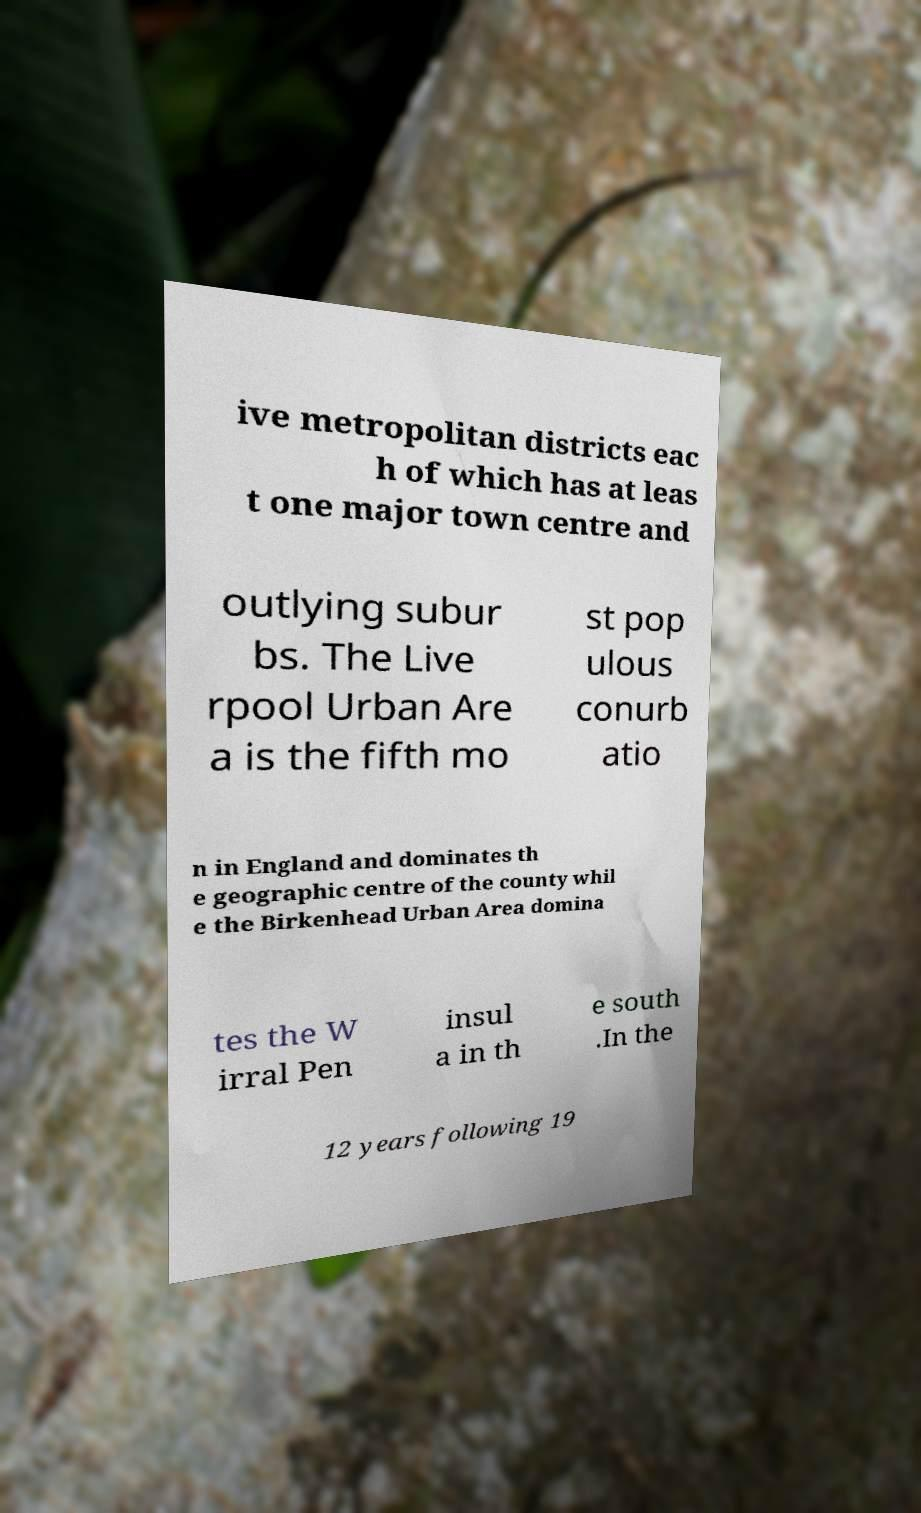Can you read and provide the text displayed in the image?This photo seems to have some interesting text. Can you extract and type it out for me? ive metropolitan districts eac h of which has at leas t one major town centre and outlying subur bs. The Live rpool Urban Are a is the fifth mo st pop ulous conurb atio n in England and dominates th e geographic centre of the county whil e the Birkenhead Urban Area domina tes the W irral Pen insul a in th e south .In the 12 years following 19 